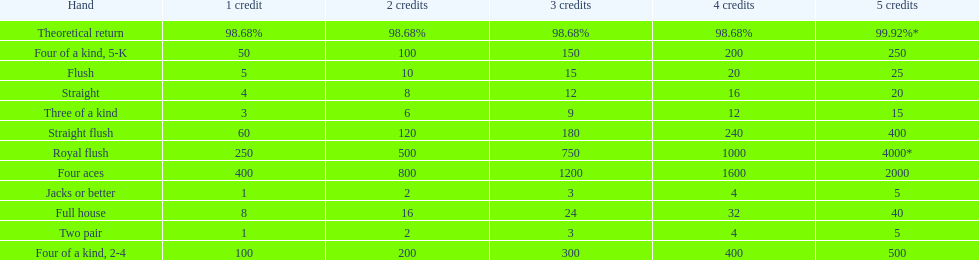What is the total amount of a 3 credit straight flush? 180. 